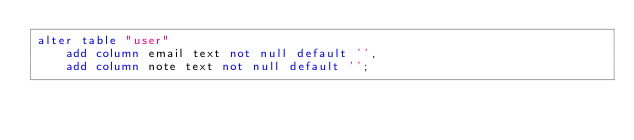Convert code to text. <code><loc_0><loc_0><loc_500><loc_500><_SQL_>alter table "user"
    add column email text not null default '',
    add column note text not null default '';</code> 